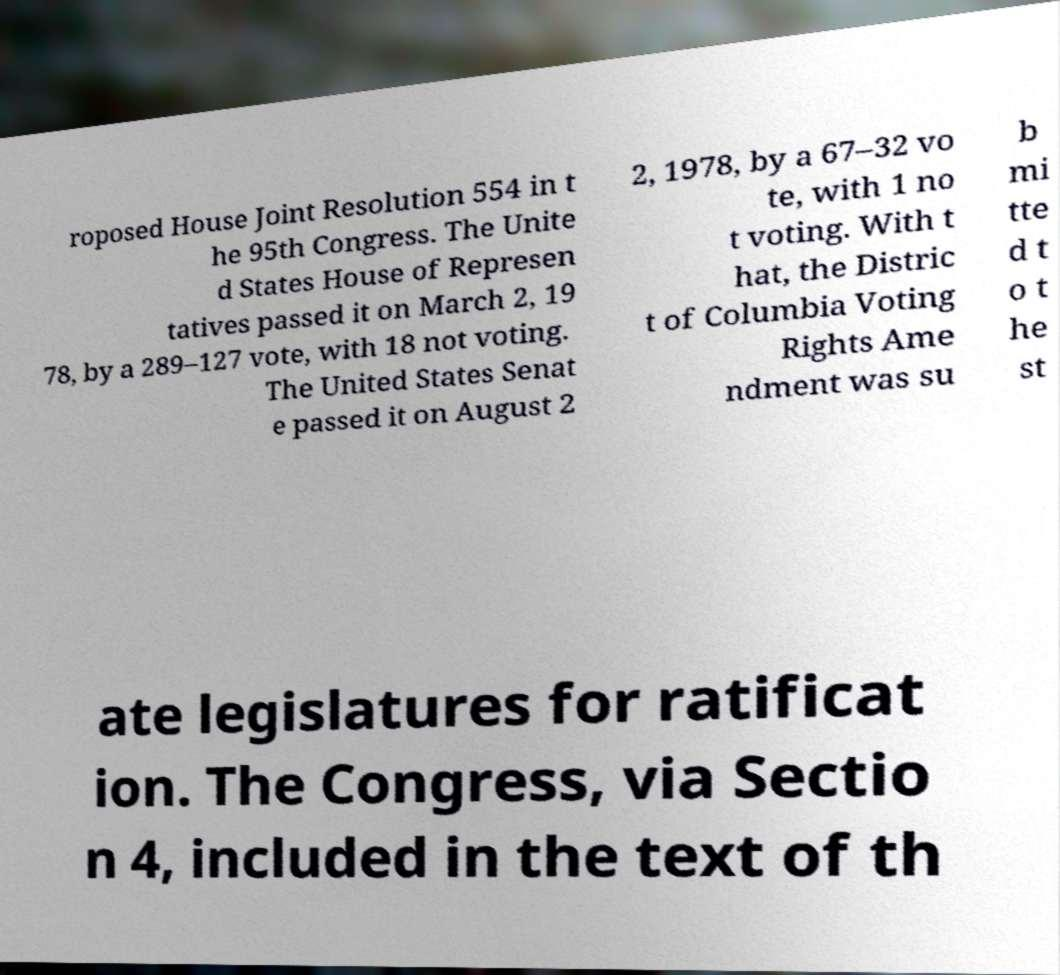Please identify and transcribe the text found in this image. roposed House Joint Resolution 554 in t he 95th Congress. The Unite d States House of Represen tatives passed it on March 2, 19 78, by a 289–127 vote, with 18 not voting. The United States Senat e passed it on August 2 2, 1978, by a 67–32 vo te, with 1 no t voting. With t hat, the Distric t of Columbia Voting Rights Ame ndment was su b mi tte d t o t he st ate legislatures for ratificat ion. The Congress, via Sectio n 4, included in the text of th 